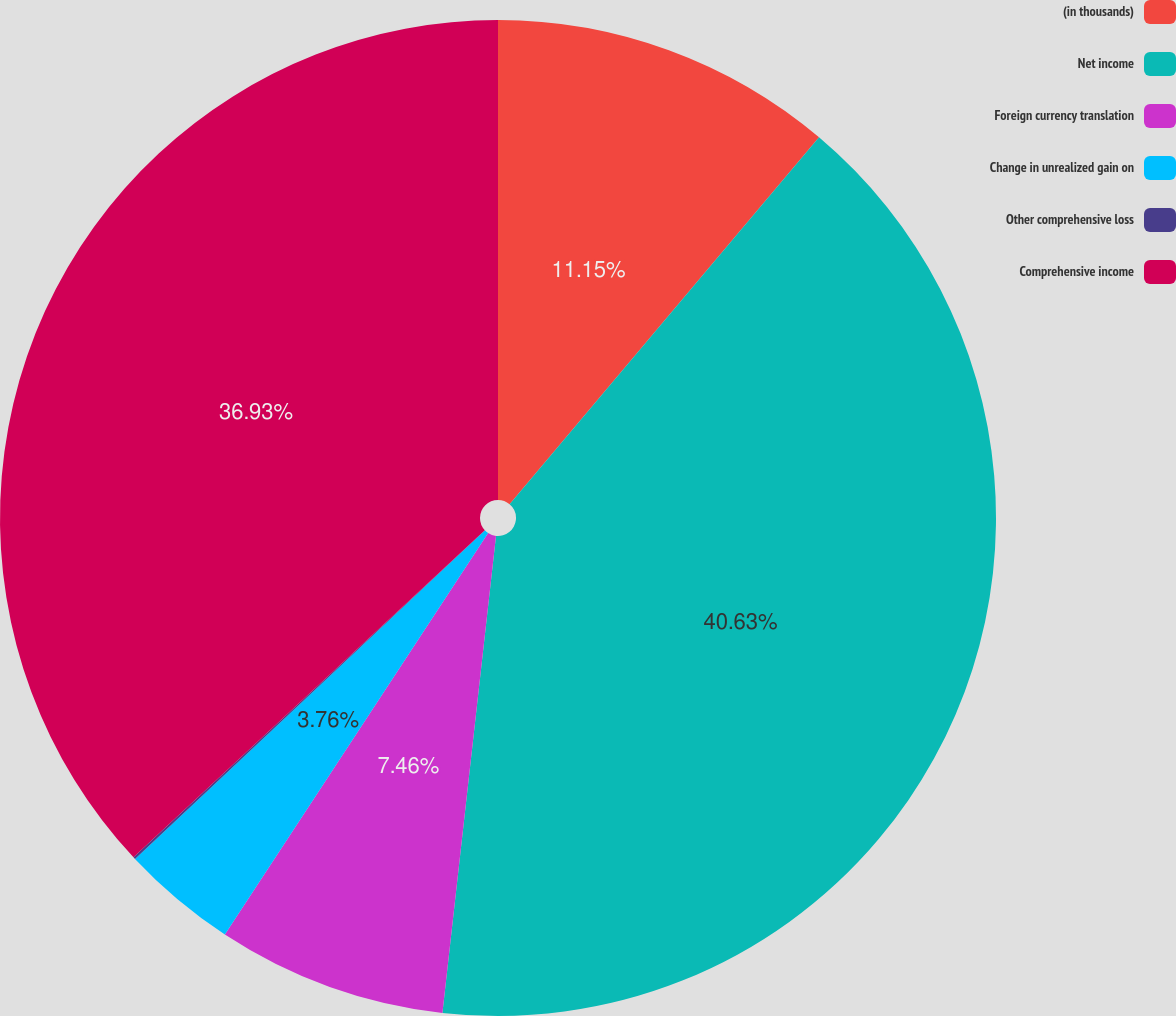Convert chart to OTSL. <chart><loc_0><loc_0><loc_500><loc_500><pie_chart><fcel>(in thousands)<fcel>Net income<fcel>Foreign currency translation<fcel>Change in unrealized gain on<fcel>Other comprehensive loss<fcel>Comprehensive income<nl><fcel>11.15%<fcel>40.63%<fcel>7.46%<fcel>3.76%<fcel>0.07%<fcel>36.93%<nl></chart> 